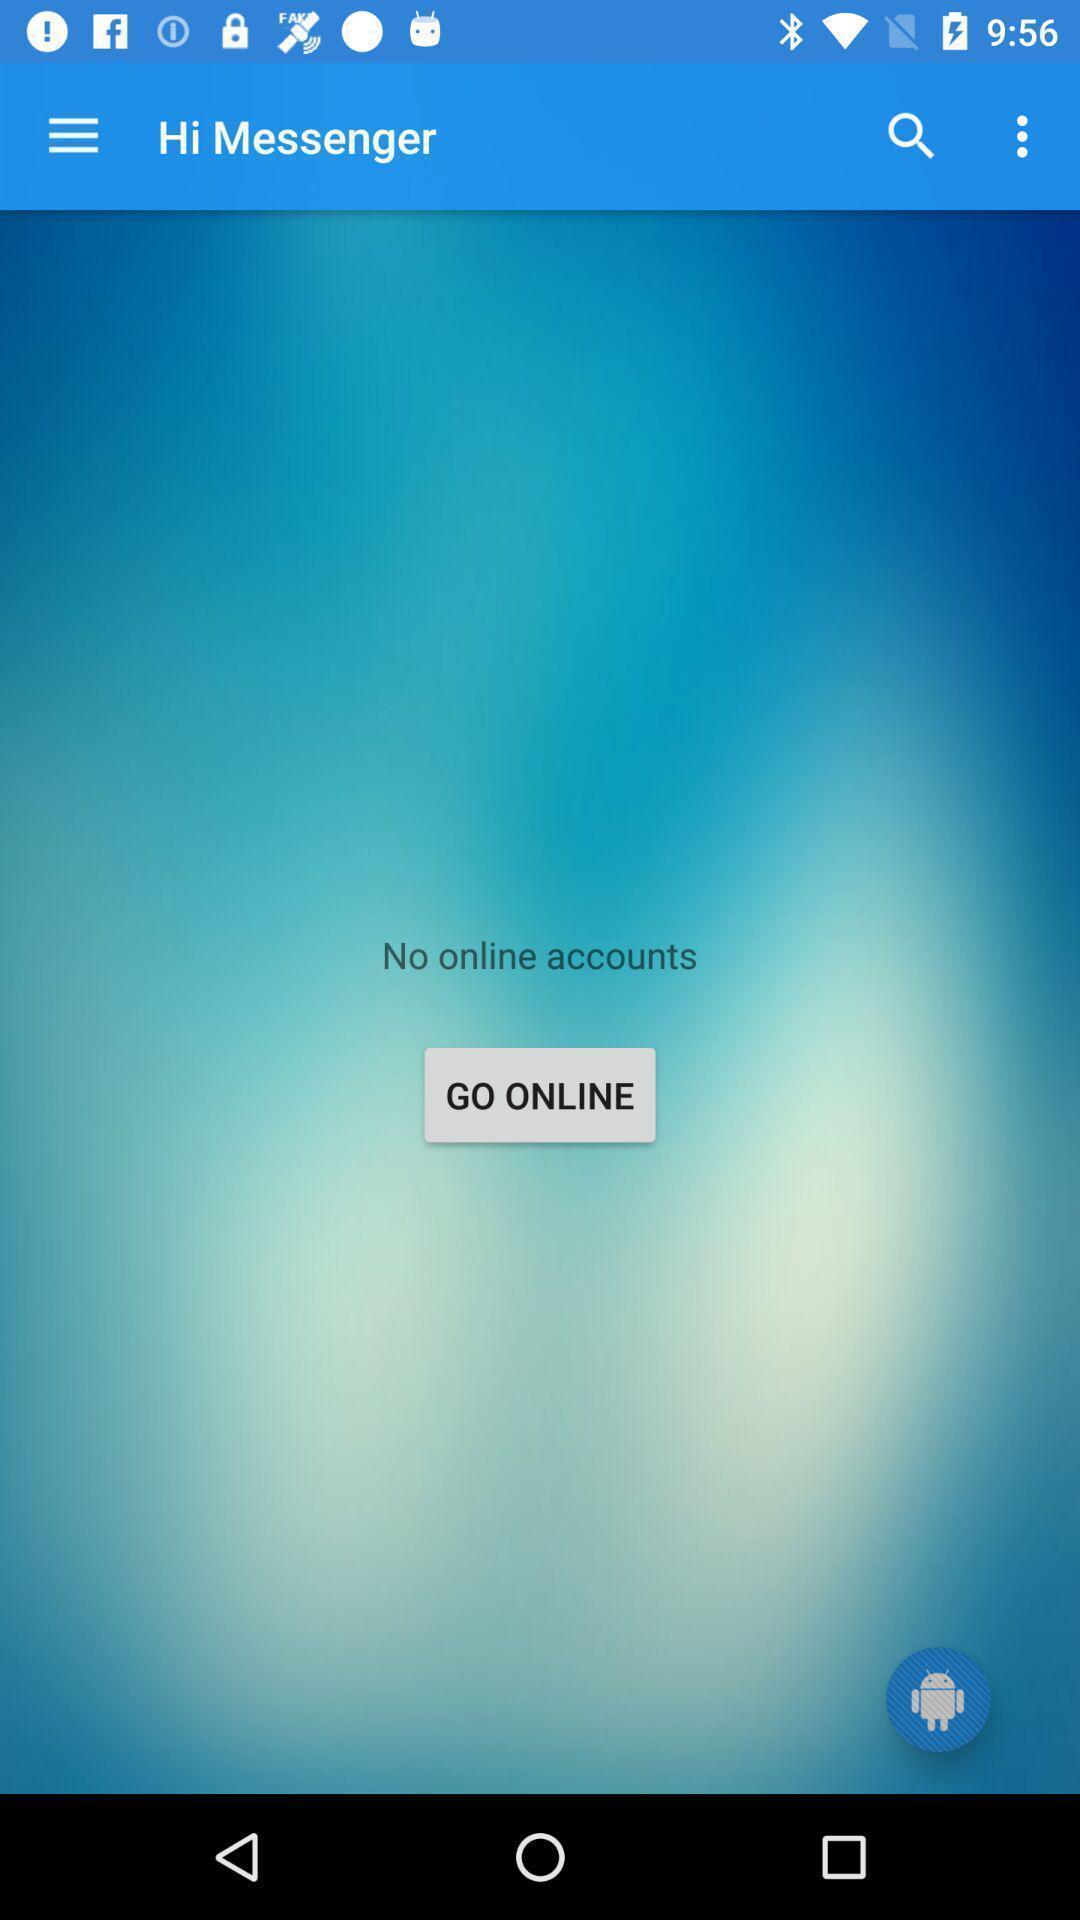Give me a narrative description of this picture. Screen shows offline accounts in a messenger. 